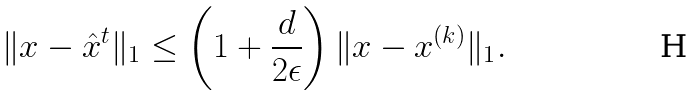<formula> <loc_0><loc_0><loc_500><loc_500>\| x - \hat { x } ^ { t } \| _ { 1 } \leq \left ( 1 + \frac { d } { 2 \epsilon } \right ) \| x - x ^ { ( k ) } \| _ { 1 } .</formula> 